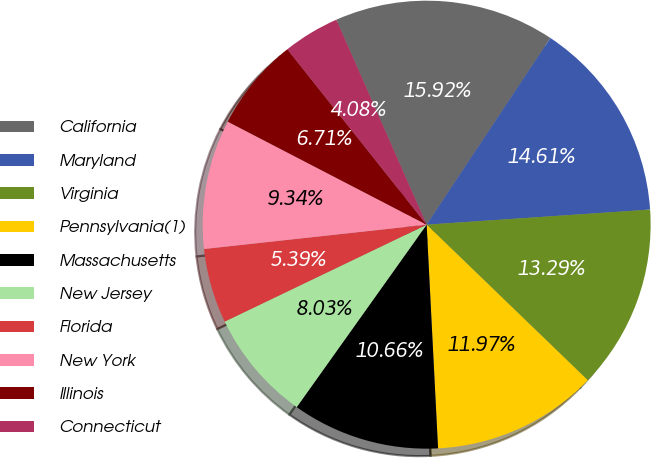Convert chart to OTSL. <chart><loc_0><loc_0><loc_500><loc_500><pie_chart><fcel>California<fcel>Maryland<fcel>Virginia<fcel>Pennsylvania(1)<fcel>Massachusetts<fcel>New Jersey<fcel>Florida<fcel>New York<fcel>Illinois<fcel>Connecticut<nl><fcel>15.92%<fcel>14.61%<fcel>13.29%<fcel>11.97%<fcel>10.66%<fcel>8.03%<fcel>5.39%<fcel>9.34%<fcel>6.71%<fcel>4.08%<nl></chart> 